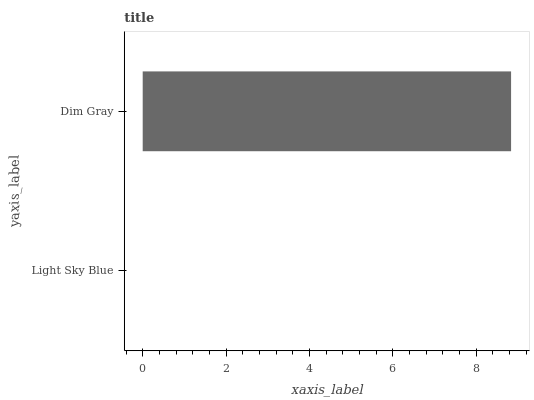Is Light Sky Blue the minimum?
Answer yes or no. Yes. Is Dim Gray the maximum?
Answer yes or no. Yes. Is Dim Gray the minimum?
Answer yes or no. No. Is Dim Gray greater than Light Sky Blue?
Answer yes or no. Yes. Is Light Sky Blue less than Dim Gray?
Answer yes or no. Yes. Is Light Sky Blue greater than Dim Gray?
Answer yes or no. No. Is Dim Gray less than Light Sky Blue?
Answer yes or no. No. Is Dim Gray the high median?
Answer yes or no. Yes. Is Light Sky Blue the low median?
Answer yes or no. Yes. Is Light Sky Blue the high median?
Answer yes or no. No. Is Dim Gray the low median?
Answer yes or no. No. 